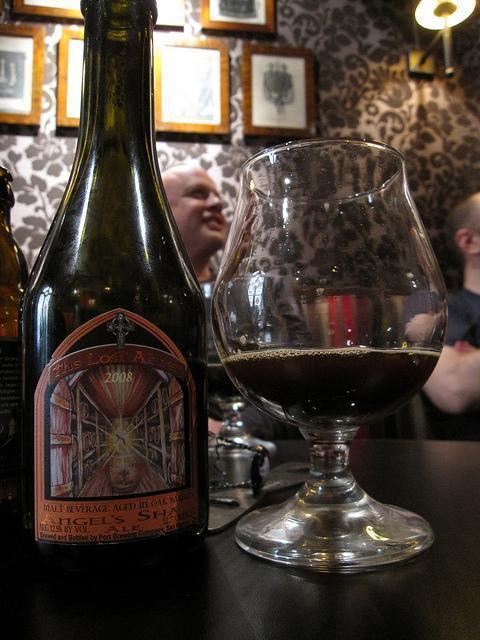What is in the glass?
Choose the right answer and clarify with the format: 'Answer: answer
Rationale: rationale.'
Options: Juice, wine, beer, gin. Answer: beer.
Rationale: There is a beer in the glass. 